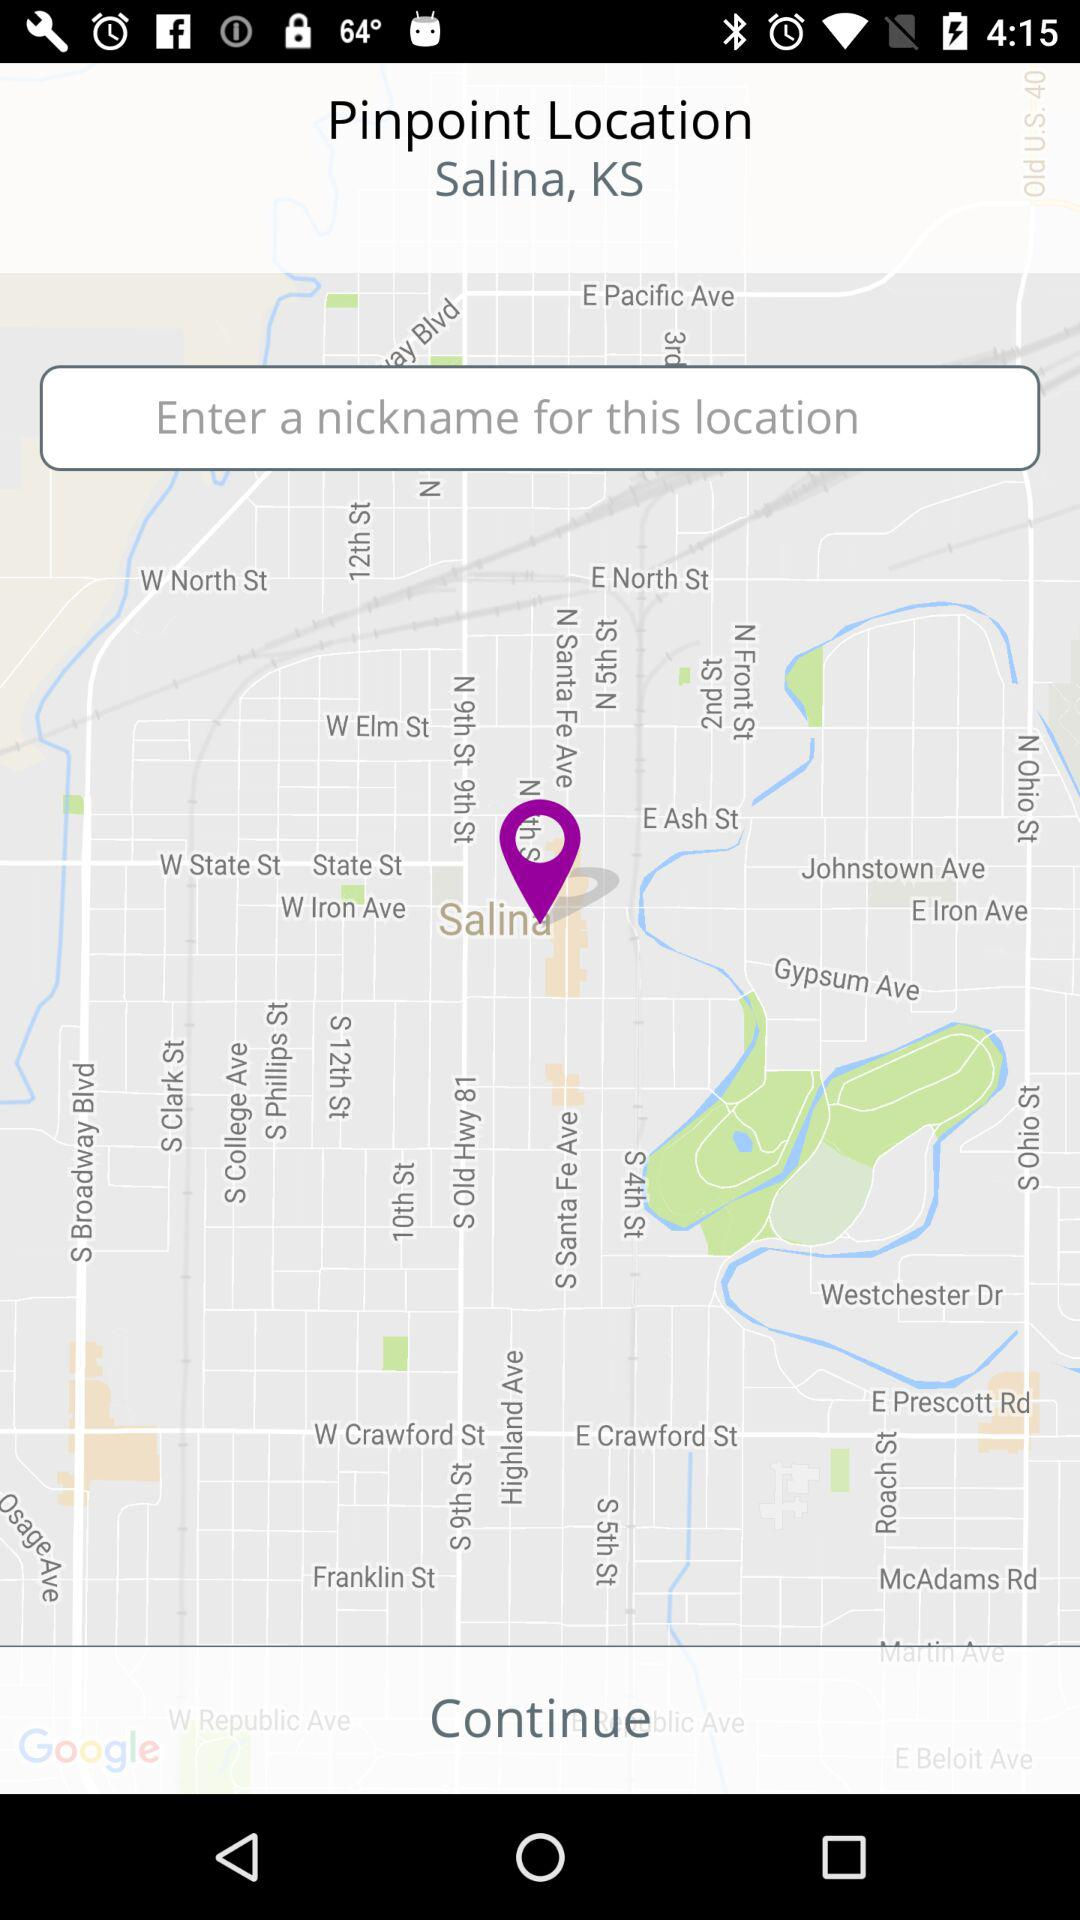What is the selected location? The selected location is Salina, KS. 